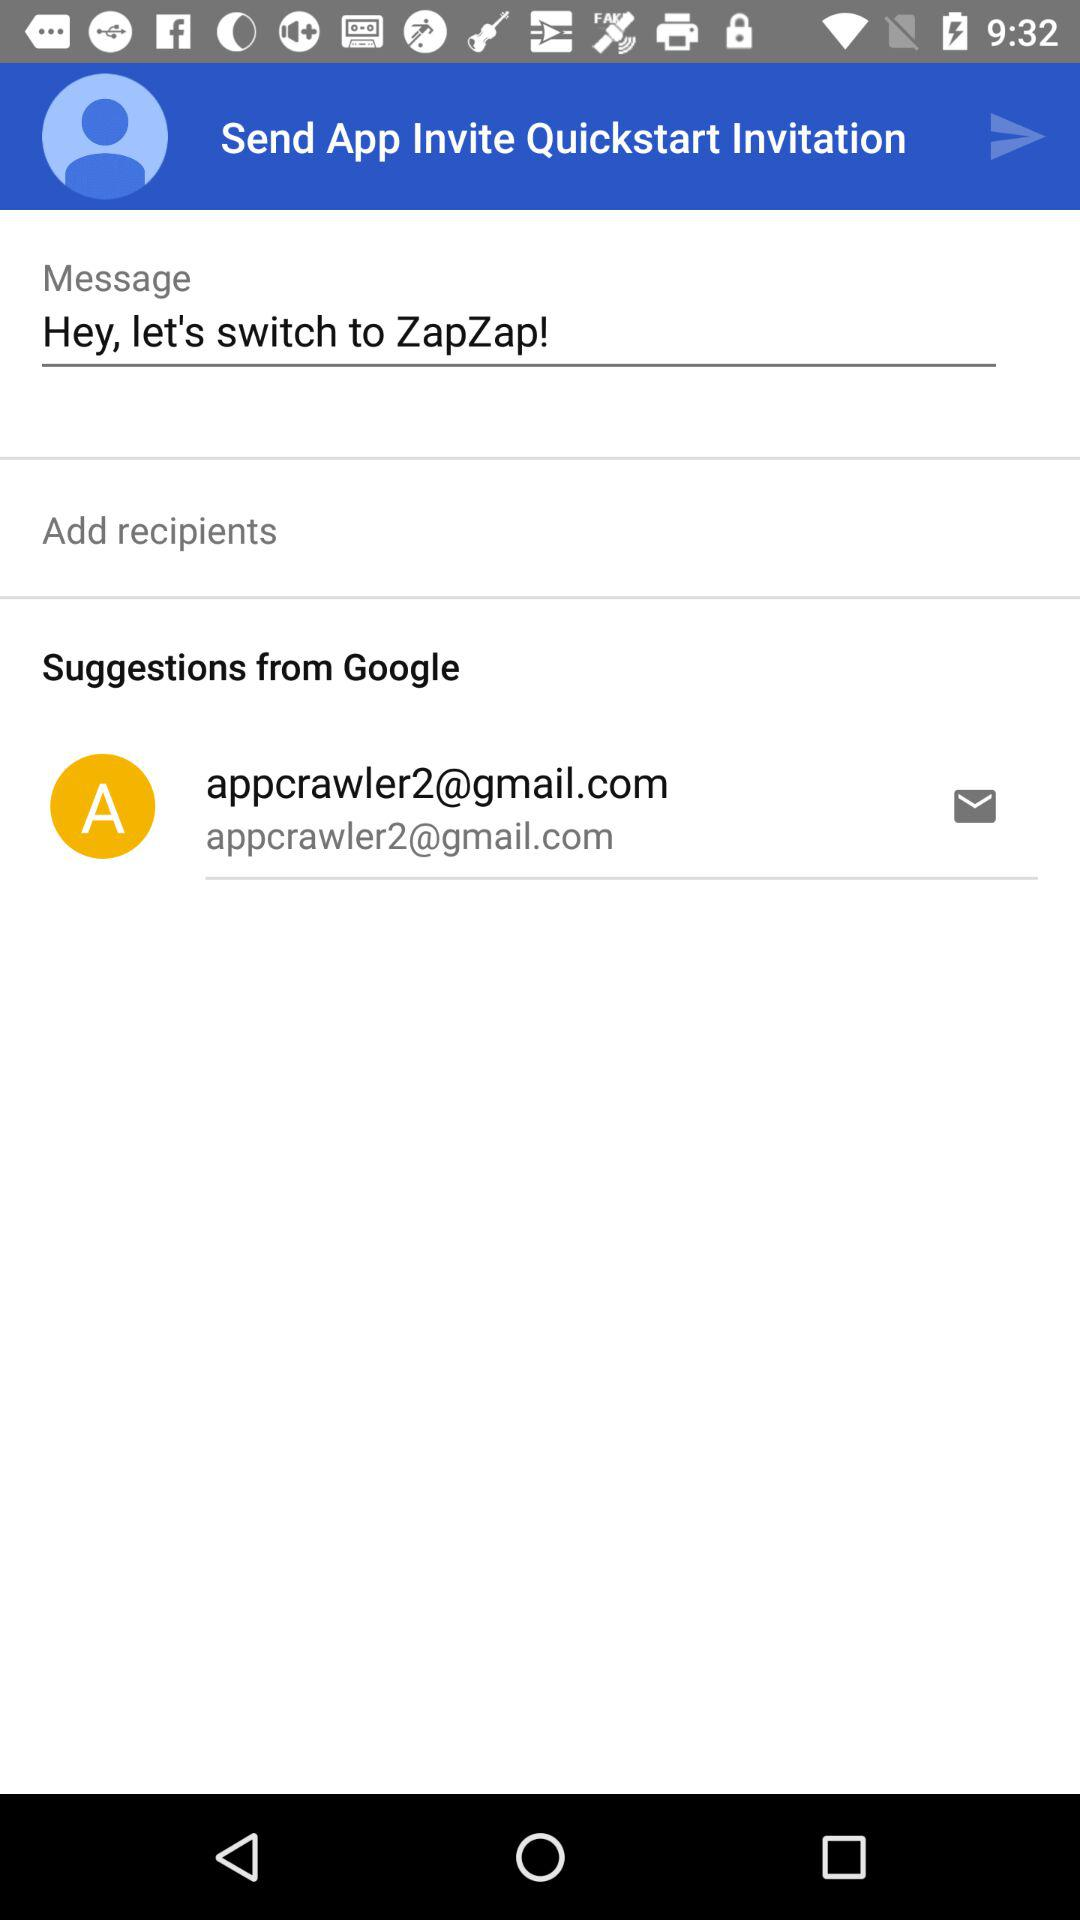What is the message? The message is "Hey, let's switch to ZapZap!". 